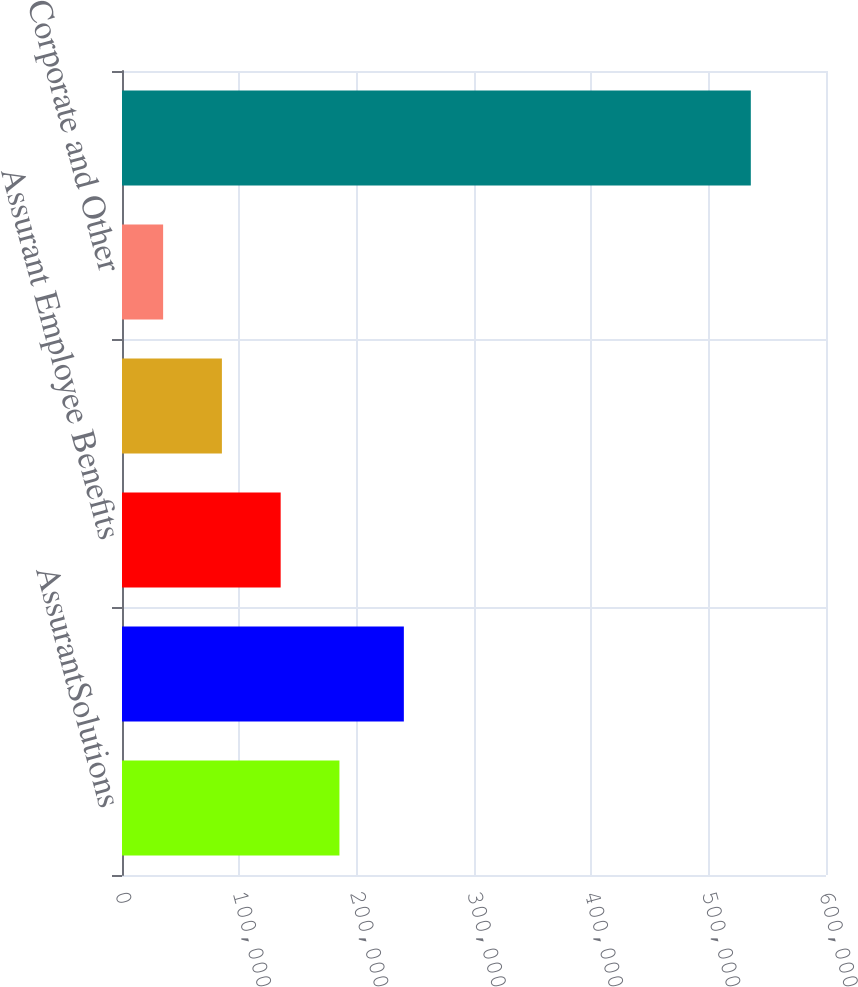Convert chart to OTSL. <chart><loc_0><loc_0><loc_500><loc_500><bar_chart><fcel>AssurantSolutions<fcel>Assurant Health<fcel>Assurant Employee Benefits<fcel>AssurantPreNeed<fcel>Corporate and Other<fcel>TotalBusinessSegments<nl><fcel>185317<fcel>240218<fcel>135230<fcel>85142.3<fcel>35055<fcel>535928<nl></chart> 